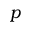Convert formula to latex. <formula><loc_0><loc_0><loc_500><loc_500>p</formula> 